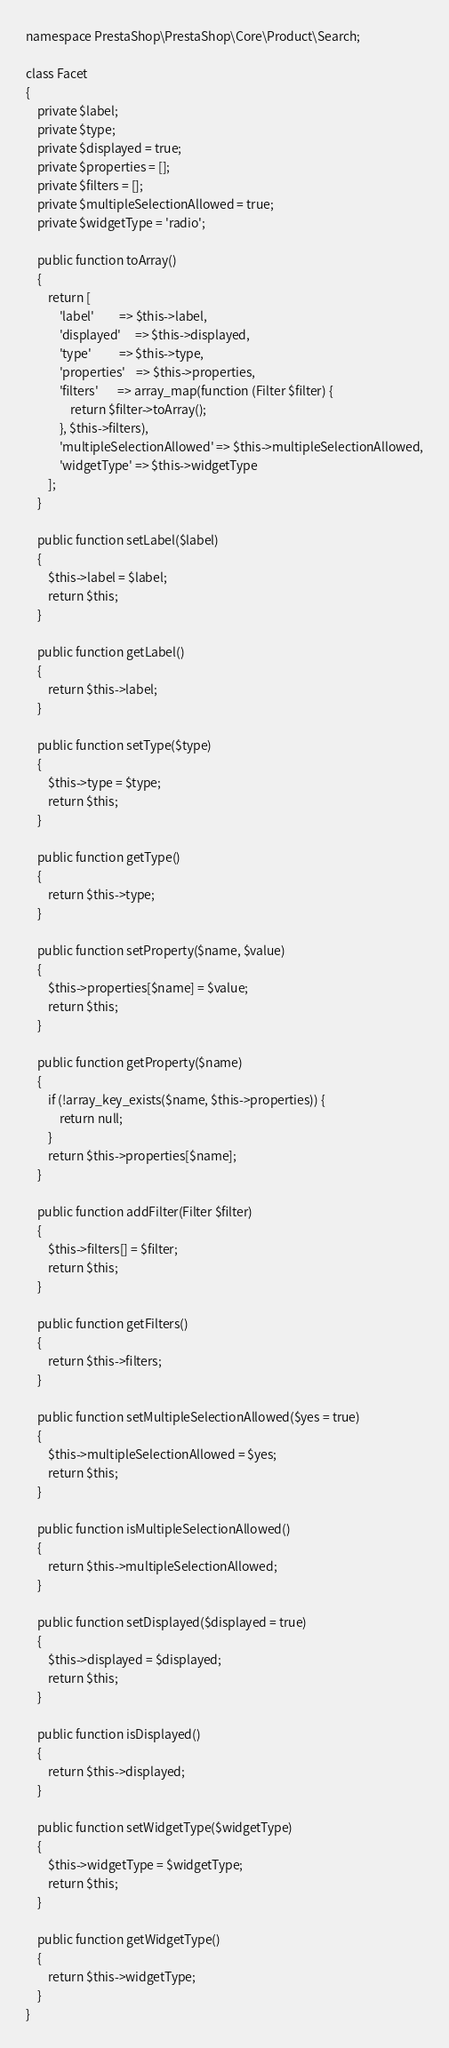<code> <loc_0><loc_0><loc_500><loc_500><_PHP_>

namespace PrestaShop\PrestaShop\Core\Product\Search;

class Facet
{
    private $label;
    private $type;
    private $displayed = true;
    private $properties = [];
    private $filters = [];
    private $multipleSelectionAllowed = true;
    private $widgetType = 'radio';

    public function toArray()
    {
        return [
            'label'         => $this->label,
            'displayed'     => $this->displayed,
            'type'          => $this->type,
            'properties'    => $this->properties,
            'filters'       => array_map(function (Filter $filter) {
                return $filter->toArray();
            }, $this->filters),
            'multipleSelectionAllowed' => $this->multipleSelectionAllowed,
            'widgetType' => $this->widgetType
        ];
    }

    public function setLabel($label)
    {
        $this->label = $label;
        return $this;
    }

    public function getLabel()
    {
        return $this->label;
    }

    public function setType($type)
    {
        $this->type = $type;
        return $this;
    }

    public function getType()
    {
        return $this->type;
    }

    public function setProperty($name, $value)
    {
        $this->properties[$name] = $value;
        return $this;
    }

    public function getProperty($name)
    {
        if (!array_key_exists($name, $this->properties)) {
            return null;
        }
        return $this->properties[$name];
    }

    public function addFilter(Filter $filter)
    {
        $this->filters[] = $filter;
        return $this;
    }

    public function getFilters()
    {
        return $this->filters;
    }

    public function setMultipleSelectionAllowed($yes = true)
    {
        $this->multipleSelectionAllowed = $yes;
        return $this;
    }

    public function isMultipleSelectionAllowed()
    {
        return $this->multipleSelectionAllowed;
    }

    public function setDisplayed($displayed = true)
    {
        $this->displayed = $displayed;
        return $this;
    }

    public function isDisplayed()
    {
        return $this->displayed;
    }

    public function setWidgetType($widgetType)
    {
        $this->widgetType = $widgetType;
        return $this;
    }

    public function getWidgetType()
    {
        return $this->widgetType;
    }
}
</code> 